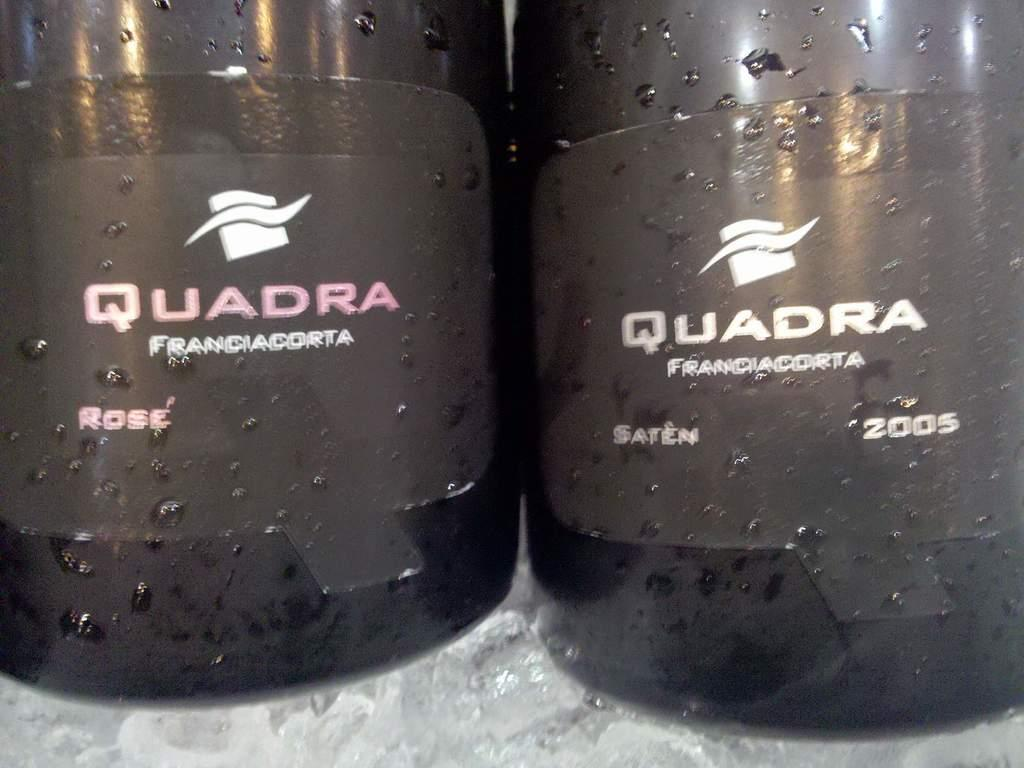<image>
Render a clear and concise summary of the photo. Two bottles of a rose and saten wine made by Quadra, one made in 2005. 